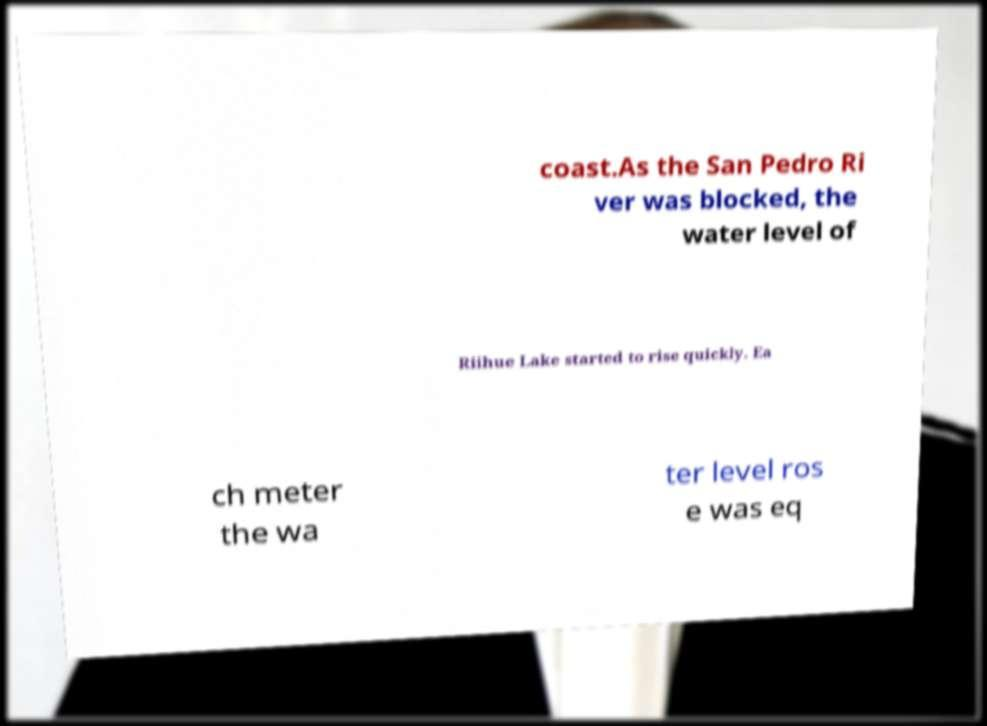Could you extract and type out the text from this image? coast.As the San Pedro Ri ver was blocked, the water level of Riihue Lake started to rise quickly. Ea ch meter the wa ter level ros e was eq 